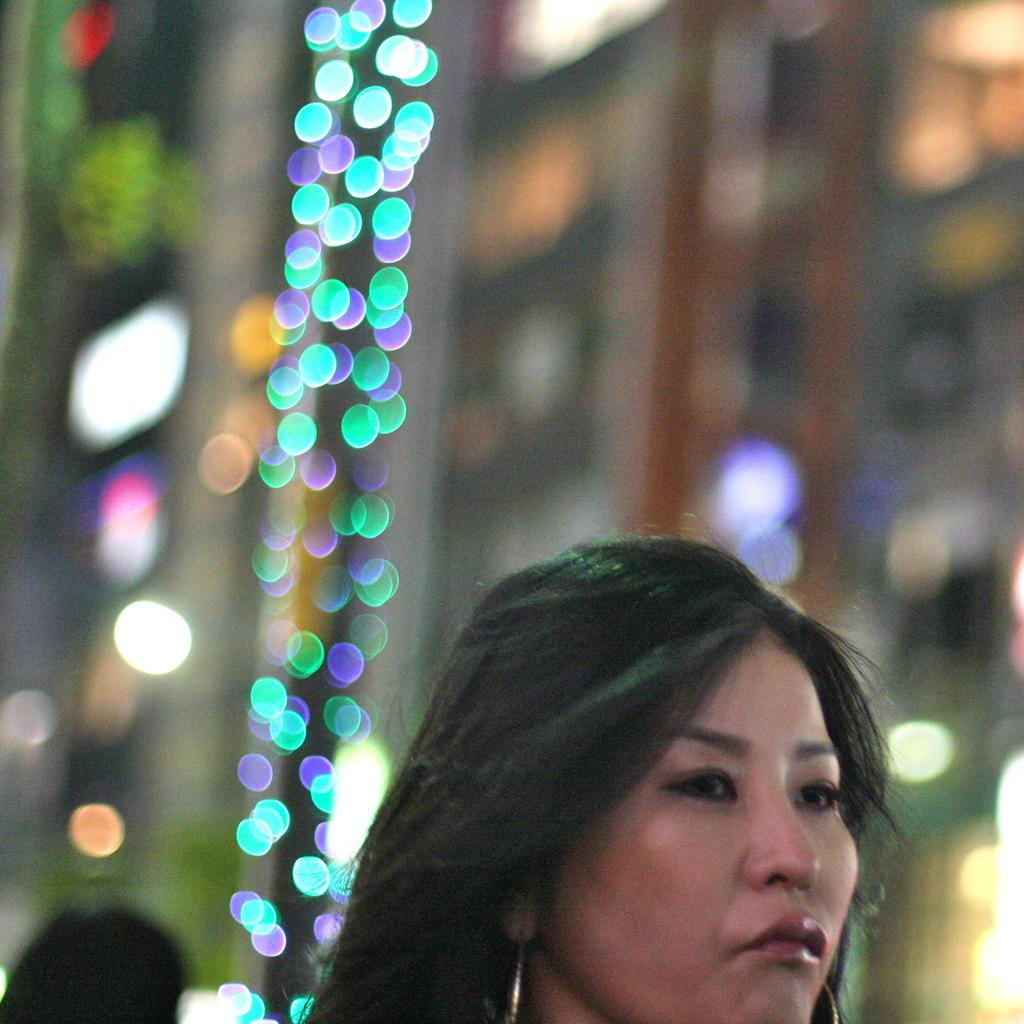What is the main subject of the image? There is a woman's face in the image. Where is the woman's face located in the image? The woman's face is at the bottom of the image. Can you describe the background of the image? The background of the image is blurry. How many women's throats can be seen in the image? There is no woman's throat visible in the image, only her face. Is there a window in the image? There is no window present in the image. 